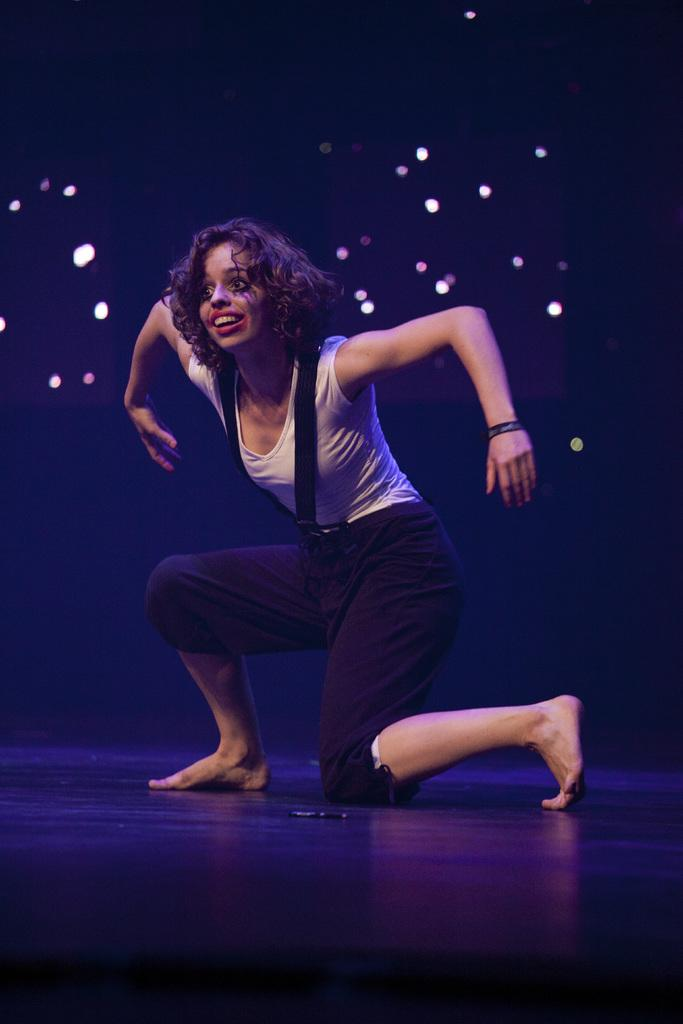What is the lady doing in the image? There is a lady performing on the stage in the image. What can be seen in the background of the image? There are lights visible in the background. Can you see the receipt for the lady's lunch on the stage? There is no mention of a lunch or a receipt in the image, so we cannot see it. 